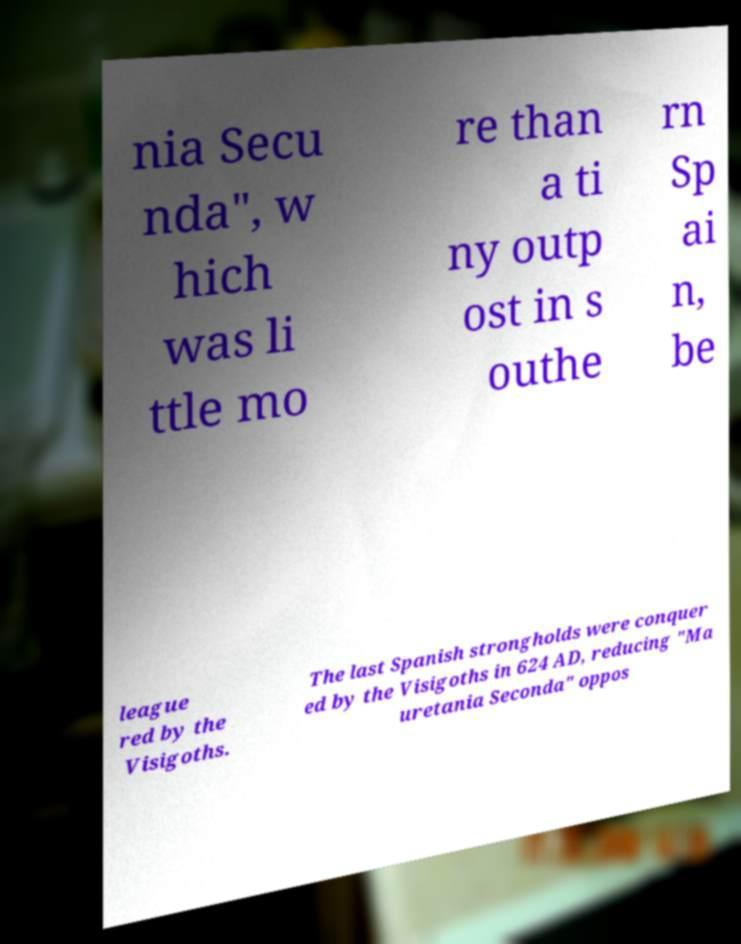Please read and relay the text visible in this image. What does it say? nia Secu nda", w hich was li ttle mo re than a ti ny outp ost in s outhe rn Sp ai n, be league red by the Visigoths. The last Spanish strongholds were conquer ed by the Visigoths in 624 AD, reducing "Ma uretania Seconda" oppos 